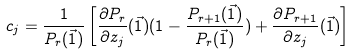<formula> <loc_0><loc_0><loc_500><loc_500>c _ { j } = \frac { 1 } { P _ { r } ( \vec { 1 } ) } \left [ \frac { \partial P _ { r } } { \partial z _ { j } } ( \vec { 1 } ) ( 1 - \frac { P _ { r + 1 } ( \vec { 1 } ) } { P _ { r } ( \vec { 1 } ) } ) + \frac { \partial P _ { r + 1 } } { \partial z _ { j } } ( \vec { 1 } ) \right ]</formula> 